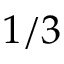<formula> <loc_0><loc_0><loc_500><loc_500>1 / 3</formula> 